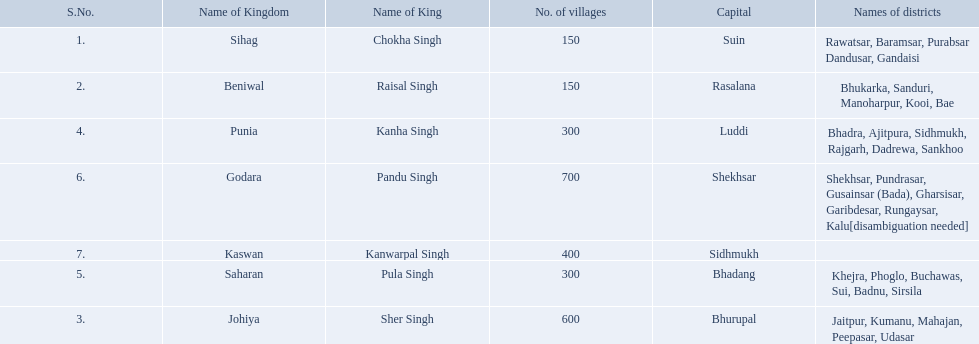What are all of the kingdoms? Sihag, Beniwal, Johiya, Punia, Saharan, Godara, Kaswan. Can you give me this table as a dict? {'header': ['S.No.', 'Name of Kingdom', 'Name of King', 'No. of villages', 'Capital', 'Names of districts'], 'rows': [['1.', 'Sihag', 'Chokha Singh', '150', 'Suin', 'Rawatsar, Baramsar, Purabsar Dandusar, Gandaisi'], ['2.', 'Beniwal', 'Raisal Singh', '150', 'Rasalana', 'Bhukarka, Sanduri, Manoharpur, Kooi, Bae'], ['4.', 'Punia', 'Kanha Singh', '300', 'Luddi', 'Bhadra, Ajitpura, Sidhmukh, Rajgarh, Dadrewa, Sankhoo'], ['6.', 'Godara', 'Pandu Singh', '700', 'Shekhsar', 'Shekhsar, Pundrasar, Gusainsar (Bada), Gharsisar, Garibdesar, Rungaysar, Kalu[disambiguation needed]'], ['7.', 'Kaswan', 'Kanwarpal Singh', '400', 'Sidhmukh', ''], ['5.', 'Saharan', 'Pula Singh', '300', 'Bhadang', 'Khejra, Phoglo, Buchawas, Sui, Badnu, Sirsila'], ['3.', 'Johiya', 'Sher Singh', '600', 'Bhurupal', 'Jaitpur, Kumanu, Mahajan, Peepasar, Udasar']]} How many villages do they contain? 150, 150, 600, 300, 300, 700, 400. How many are in godara? 700. Which kingdom comes next in highest amount of villages? Johiya. Which kingdom contained the least amount of villages along with sihag? Beniwal. Which kingdom contained the most villages? Godara. Which village was tied at second most villages with godara? Johiya. 